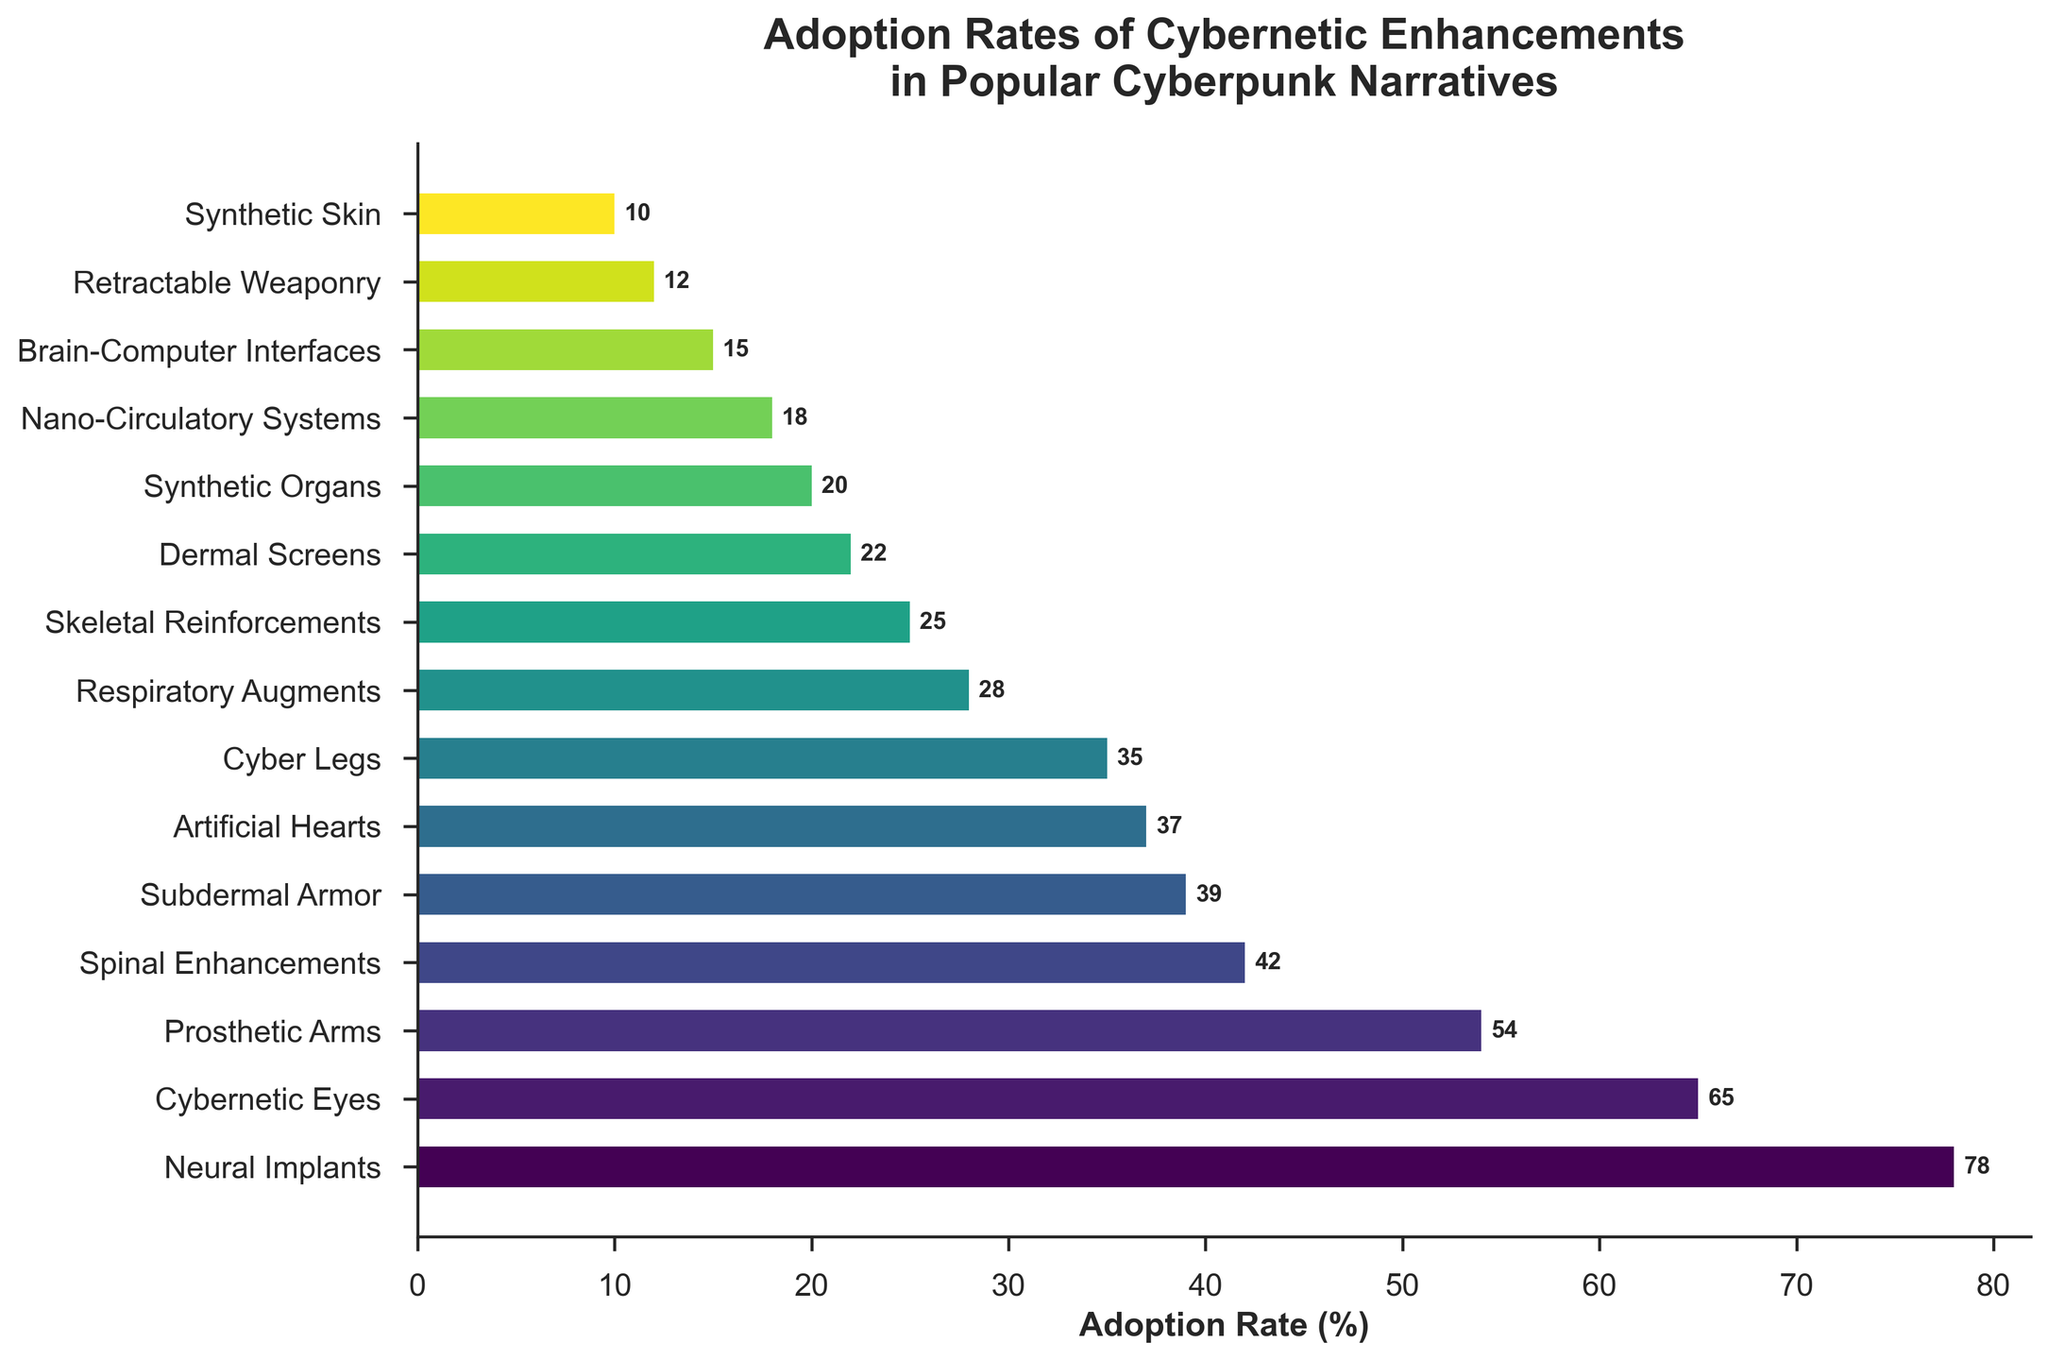Which body part has the highest adoption rate? To determine the body part with the highest adoption rate, look at the bar representing the implementation rate and find the longest bar.
Answer: Neural Implants Which body parts have an adoption rate of over 60%? Identify bars with adoption rates exceeding 60% and note their corresponding body parts.
Answer: Neural Implants, Cybernetic Eyes What is the difference in adoption rates between Subdermal Armor and Cyber Legs? Find the adoption rates of Subdermal Armor (39%) and Cyber Legs (35%), then subtract the latter from the former, 39 - 35.
Answer: 4% Which enhancement has the closest adoption rate to 20%? Look for the bar that is visually closest to 20% and check its label.
Answer: Synthetic Organs How much higher is the adoption rate of Brain-Computer Interfaces compared to Retractable Weaponry? Locate the adoption rates for Brain-Computer Interfaces (15%) and Retractable Weaponry (12%) and calculate their difference, 15 - 12.
Answer: 3% Rank the following in terms of adoption rate from highest to lowest: Cybernetic Eyes, Synthetic Organs, Neural Implants, and Prosthetic Arms. Determine the adoption rates for the listed parts: Neural Implants (78%), Cybernetic Eyes (65%), Prosthetic Arms (54%), and Synthetic Organs (20%), then arrange them in descending order.
Answer: Neural Implants > Cybernetic Eyes > Prosthetic Arms > Synthetic Organs What is the combined adoption rate of Respiratory Augments, Skeletal Reinforcements, and Dermal Screens? Add the adoption rates of Respiratory Augments (28%), Skeletal Reinforcements (25%), and Dermal Screens (22%) together, 28 + 25 + 22.
Answer: 75% Between Artificial Hearts and Synthetic Skin, which has a lower adoption rate, and by how much? Check the adoption rates of Artificial Hearts (37%) and Synthetic Skin (10%). Subtract the lower rate from the higher rate to find the difference, 37 - 10.
Answer: Synthetic Skin, 27% Identify the median adoption rate among all the listed body parts. Organize the adoption rates in ascending order and find the middle value. The middle 7 rates out of 15 are: 18, 20, 22, 25, 28, 35, 37, with the median being the value in the 4th position.
Answer: 25% Compare the adoption rates of Prosthetic Arms and Subdermal Armor and state which is more popular. Look at the adoption rates for Prosthetic Arms (54%) and Subdermal Armor (39%) to identify which is higher.
Answer: Prosthetic Arms 